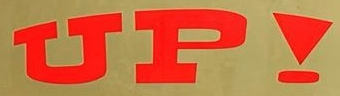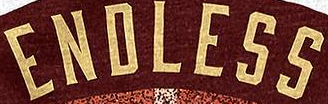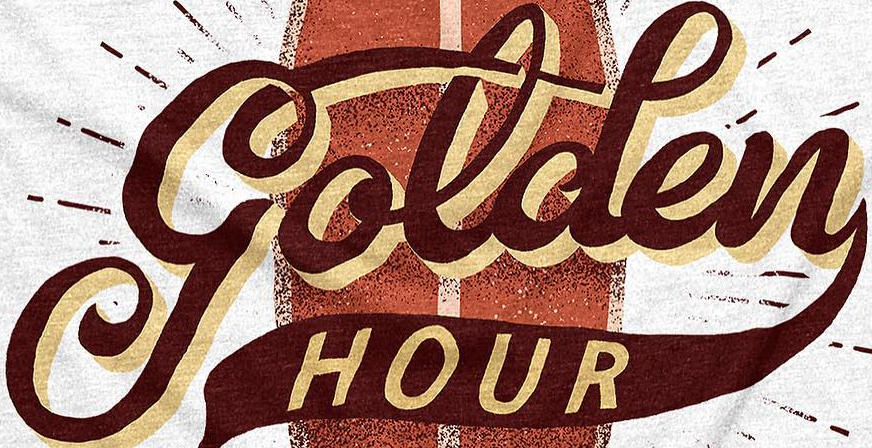What words are shown in these images in order, separated by a semicolon? UP!; ENDLESS; golden 